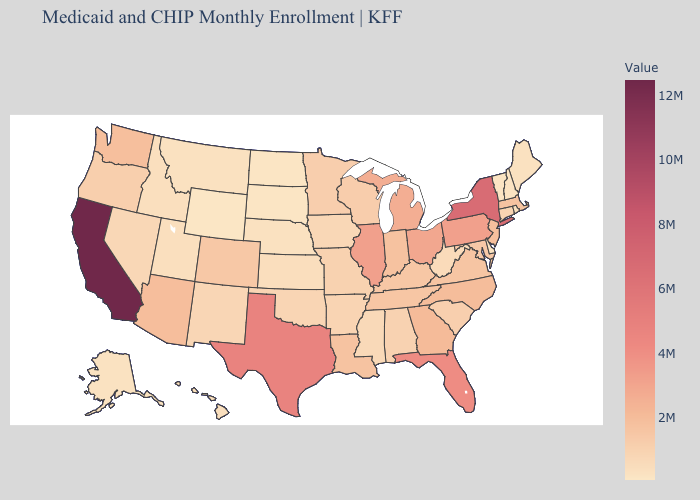Does California have the highest value in the USA?
Be succinct. Yes. Does Arizona have a lower value than South Dakota?
Write a very short answer. No. Does Wyoming have the lowest value in the USA?
Be succinct. Yes. Is the legend a continuous bar?
Answer briefly. Yes. Among the states that border Montana , which have the lowest value?
Quick response, please. Wyoming. 